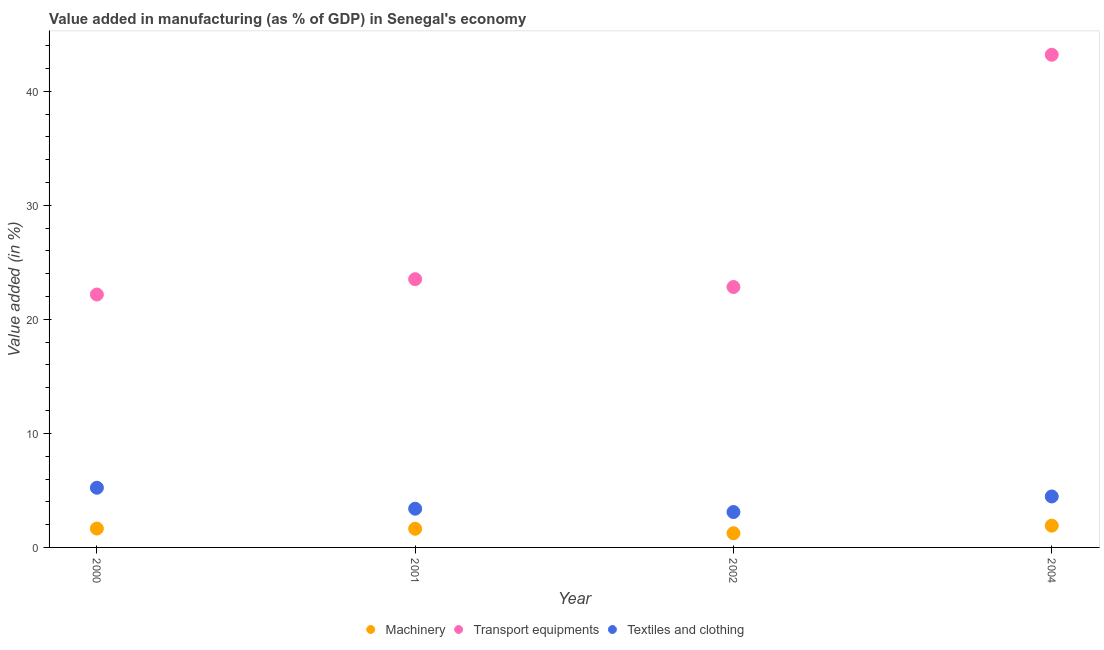What is the value added in manufacturing transport equipments in 2000?
Your response must be concise. 22.18. Across all years, what is the maximum value added in manufacturing textile and clothing?
Your answer should be very brief. 5.23. Across all years, what is the minimum value added in manufacturing transport equipments?
Give a very brief answer. 22.18. What is the total value added in manufacturing machinery in the graph?
Offer a terse response. 6.45. What is the difference between the value added in manufacturing transport equipments in 2001 and that in 2004?
Keep it short and to the point. -19.68. What is the difference between the value added in manufacturing machinery in 2002 and the value added in manufacturing transport equipments in 2004?
Provide a short and direct response. -41.96. What is the average value added in manufacturing transport equipments per year?
Offer a very short reply. 27.93. In the year 2002, what is the difference between the value added in manufacturing machinery and value added in manufacturing textile and clothing?
Ensure brevity in your answer.  -1.86. What is the ratio of the value added in manufacturing machinery in 2001 to that in 2002?
Keep it short and to the point. 1.31. Is the value added in manufacturing transport equipments in 2000 less than that in 2001?
Your response must be concise. Yes. What is the difference between the highest and the second highest value added in manufacturing textile and clothing?
Ensure brevity in your answer.  0.76. What is the difference between the highest and the lowest value added in manufacturing textile and clothing?
Offer a terse response. 2.13. Is the sum of the value added in manufacturing machinery in 2000 and 2002 greater than the maximum value added in manufacturing transport equipments across all years?
Keep it short and to the point. No. Is the value added in manufacturing transport equipments strictly greater than the value added in manufacturing machinery over the years?
Your answer should be very brief. Yes. How many dotlines are there?
Your answer should be compact. 3. What is the difference between two consecutive major ticks on the Y-axis?
Offer a very short reply. 10. Are the values on the major ticks of Y-axis written in scientific E-notation?
Keep it short and to the point. No. Does the graph contain any zero values?
Your answer should be compact. No. Does the graph contain grids?
Your answer should be compact. No. How many legend labels are there?
Offer a terse response. 3. What is the title of the graph?
Offer a terse response. Value added in manufacturing (as % of GDP) in Senegal's economy. Does "Transport" appear as one of the legend labels in the graph?
Your response must be concise. No. What is the label or title of the X-axis?
Ensure brevity in your answer.  Year. What is the label or title of the Y-axis?
Offer a terse response. Value added (in %). What is the Value added (in %) of Machinery in 2000?
Give a very brief answer. 1.66. What is the Value added (in %) in Transport equipments in 2000?
Ensure brevity in your answer.  22.18. What is the Value added (in %) in Textiles and clothing in 2000?
Ensure brevity in your answer.  5.23. What is the Value added (in %) in Machinery in 2001?
Ensure brevity in your answer.  1.64. What is the Value added (in %) of Transport equipments in 2001?
Ensure brevity in your answer.  23.52. What is the Value added (in %) of Textiles and clothing in 2001?
Your response must be concise. 3.39. What is the Value added (in %) in Machinery in 2002?
Your answer should be very brief. 1.25. What is the Value added (in %) in Transport equipments in 2002?
Ensure brevity in your answer.  22.84. What is the Value added (in %) of Textiles and clothing in 2002?
Your answer should be very brief. 3.1. What is the Value added (in %) of Machinery in 2004?
Provide a short and direct response. 1.91. What is the Value added (in %) in Transport equipments in 2004?
Offer a very short reply. 43.2. What is the Value added (in %) in Textiles and clothing in 2004?
Ensure brevity in your answer.  4.47. Across all years, what is the maximum Value added (in %) in Machinery?
Keep it short and to the point. 1.91. Across all years, what is the maximum Value added (in %) in Transport equipments?
Provide a succinct answer. 43.2. Across all years, what is the maximum Value added (in %) of Textiles and clothing?
Give a very brief answer. 5.23. Across all years, what is the minimum Value added (in %) in Machinery?
Offer a terse response. 1.25. Across all years, what is the minimum Value added (in %) of Transport equipments?
Make the answer very short. 22.18. Across all years, what is the minimum Value added (in %) in Textiles and clothing?
Keep it short and to the point. 3.1. What is the total Value added (in %) in Machinery in the graph?
Offer a terse response. 6.45. What is the total Value added (in %) of Transport equipments in the graph?
Keep it short and to the point. 111.74. What is the total Value added (in %) of Textiles and clothing in the graph?
Keep it short and to the point. 16.2. What is the difference between the Value added (in %) in Machinery in 2000 and that in 2001?
Provide a succinct answer. 0.02. What is the difference between the Value added (in %) in Transport equipments in 2000 and that in 2001?
Offer a terse response. -1.34. What is the difference between the Value added (in %) in Textiles and clothing in 2000 and that in 2001?
Provide a succinct answer. 1.84. What is the difference between the Value added (in %) of Machinery in 2000 and that in 2002?
Give a very brief answer. 0.41. What is the difference between the Value added (in %) of Transport equipments in 2000 and that in 2002?
Provide a short and direct response. -0.66. What is the difference between the Value added (in %) in Textiles and clothing in 2000 and that in 2002?
Your answer should be very brief. 2.13. What is the difference between the Value added (in %) in Machinery in 2000 and that in 2004?
Ensure brevity in your answer.  -0.25. What is the difference between the Value added (in %) of Transport equipments in 2000 and that in 2004?
Provide a succinct answer. -21.02. What is the difference between the Value added (in %) in Textiles and clothing in 2000 and that in 2004?
Offer a very short reply. 0.76. What is the difference between the Value added (in %) in Machinery in 2001 and that in 2002?
Keep it short and to the point. 0.39. What is the difference between the Value added (in %) in Transport equipments in 2001 and that in 2002?
Offer a terse response. 0.69. What is the difference between the Value added (in %) in Textiles and clothing in 2001 and that in 2002?
Your answer should be very brief. 0.29. What is the difference between the Value added (in %) in Machinery in 2001 and that in 2004?
Ensure brevity in your answer.  -0.27. What is the difference between the Value added (in %) of Transport equipments in 2001 and that in 2004?
Keep it short and to the point. -19.68. What is the difference between the Value added (in %) in Textiles and clothing in 2001 and that in 2004?
Give a very brief answer. -1.08. What is the difference between the Value added (in %) of Machinery in 2002 and that in 2004?
Provide a succinct answer. -0.66. What is the difference between the Value added (in %) of Transport equipments in 2002 and that in 2004?
Make the answer very short. -20.36. What is the difference between the Value added (in %) of Textiles and clothing in 2002 and that in 2004?
Provide a short and direct response. -1.37. What is the difference between the Value added (in %) of Machinery in 2000 and the Value added (in %) of Transport equipments in 2001?
Provide a short and direct response. -21.87. What is the difference between the Value added (in %) in Machinery in 2000 and the Value added (in %) in Textiles and clothing in 2001?
Your answer should be very brief. -1.74. What is the difference between the Value added (in %) of Transport equipments in 2000 and the Value added (in %) of Textiles and clothing in 2001?
Keep it short and to the point. 18.78. What is the difference between the Value added (in %) in Machinery in 2000 and the Value added (in %) in Transport equipments in 2002?
Make the answer very short. -21.18. What is the difference between the Value added (in %) in Machinery in 2000 and the Value added (in %) in Textiles and clothing in 2002?
Offer a terse response. -1.45. What is the difference between the Value added (in %) in Transport equipments in 2000 and the Value added (in %) in Textiles and clothing in 2002?
Your response must be concise. 19.07. What is the difference between the Value added (in %) of Machinery in 2000 and the Value added (in %) of Transport equipments in 2004?
Provide a succinct answer. -41.55. What is the difference between the Value added (in %) of Machinery in 2000 and the Value added (in %) of Textiles and clothing in 2004?
Make the answer very short. -2.81. What is the difference between the Value added (in %) of Transport equipments in 2000 and the Value added (in %) of Textiles and clothing in 2004?
Ensure brevity in your answer.  17.71. What is the difference between the Value added (in %) of Machinery in 2001 and the Value added (in %) of Transport equipments in 2002?
Your response must be concise. -21.2. What is the difference between the Value added (in %) in Machinery in 2001 and the Value added (in %) in Textiles and clothing in 2002?
Provide a short and direct response. -1.47. What is the difference between the Value added (in %) of Transport equipments in 2001 and the Value added (in %) of Textiles and clothing in 2002?
Provide a succinct answer. 20.42. What is the difference between the Value added (in %) of Machinery in 2001 and the Value added (in %) of Transport equipments in 2004?
Ensure brevity in your answer.  -41.56. What is the difference between the Value added (in %) in Machinery in 2001 and the Value added (in %) in Textiles and clothing in 2004?
Make the answer very short. -2.83. What is the difference between the Value added (in %) in Transport equipments in 2001 and the Value added (in %) in Textiles and clothing in 2004?
Provide a succinct answer. 19.05. What is the difference between the Value added (in %) in Machinery in 2002 and the Value added (in %) in Transport equipments in 2004?
Provide a succinct answer. -41.96. What is the difference between the Value added (in %) of Machinery in 2002 and the Value added (in %) of Textiles and clothing in 2004?
Make the answer very short. -3.22. What is the difference between the Value added (in %) in Transport equipments in 2002 and the Value added (in %) in Textiles and clothing in 2004?
Your answer should be compact. 18.37. What is the average Value added (in %) of Machinery per year?
Ensure brevity in your answer.  1.61. What is the average Value added (in %) of Transport equipments per year?
Provide a short and direct response. 27.93. What is the average Value added (in %) in Textiles and clothing per year?
Your answer should be compact. 4.05. In the year 2000, what is the difference between the Value added (in %) in Machinery and Value added (in %) in Transport equipments?
Offer a very short reply. -20.52. In the year 2000, what is the difference between the Value added (in %) of Machinery and Value added (in %) of Textiles and clothing?
Provide a succinct answer. -3.58. In the year 2000, what is the difference between the Value added (in %) in Transport equipments and Value added (in %) in Textiles and clothing?
Your answer should be compact. 16.94. In the year 2001, what is the difference between the Value added (in %) in Machinery and Value added (in %) in Transport equipments?
Ensure brevity in your answer.  -21.89. In the year 2001, what is the difference between the Value added (in %) of Machinery and Value added (in %) of Textiles and clothing?
Your answer should be compact. -1.76. In the year 2001, what is the difference between the Value added (in %) of Transport equipments and Value added (in %) of Textiles and clothing?
Keep it short and to the point. 20.13. In the year 2002, what is the difference between the Value added (in %) in Machinery and Value added (in %) in Transport equipments?
Provide a succinct answer. -21.59. In the year 2002, what is the difference between the Value added (in %) in Machinery and Value added (in %) in Textiles and clothing?
Provide a succinct answer. -1.86. In the year 2002, what is the difference between the Value added (in %) in Transport equipments and Value added (in %) in Textiles and clothing?
Make the answer very short. 19.73. In the year 2004, what is the difference between the Value added (in %) in Machinery and Value added (in %) in Transport equipments?
Provide a short and direct response. -41.29. In the year 2004, what is the difference between the Value added (in %) in Machinery and Value added (in %) in Textiles and clothing?
Keep it short and to the point. -2.56. In the year 2004, what is the difference between the Value added (in %) of Transport equipments and Value added (in %) of Textiles and clothing?
Make the answer very short. 38.73. What is the ratio of the Value added (in %) in Machinery in 2000 to that in 2001?
Give a very brief answer. 1.01. What is the ratio of the Value added (in %) in Transport equipments in 2000 to that in 2001?
Give a very brief answer. 0.94. What is the ratio of the Value added (in %) of Textiles and clothing in 2000 to that in 2001?
Give a very brief answer. 1.54. What is the ratio of the Value added (in %) in Machinery in 2000 to that in 2002?
Your answer should be very brief. 1.33. What is the ratio of the Value added (in %) in Transport equipments in 2000 to that in 2002?
Your answer should be compact. 0.97. What is the ratio of the Value added (in %) of Textiles and clothing in 2000 to that in 2002?
Provide a succinct answer. 1.69. What is the ratio of the Value added (in %) of Machinery in 2000 to that in 2004?
Provide a succinct answer. 0.87. What is the ratio of the Value added (in %) in Transport equipments in 2000 to that in 2004?
Your answer should be compact. 0.51. What is the ratio of the Value added (in %) of Textiles and clothing in 2000 to that in 2004?
Offer a very short reply. 1.17. What is the ratio of the Value added (in %) in Machinery in 2001 to that in 2002?
Provide a succinct answer. 1.31. What is the ratio of the Value added (in %) of Textiles and clothing in 2001 to that in 2002?
Provide a succinct answer. 1.09. What is the ratio of the Value added (in %) of Machinery in 2001 to that in 2004?
Give a very brief answer. 0.86. What is the ratio of the Value added (in %) in Transport equipments in 2001 to that in 2004?
Provide a short and direct response. 0.54. What is the ratio of the Value added (in %) in Textiles and clothing in 2001 to that in 2004?
Give a very brief answer. 0.76. What is the ratio of the Value added (in %) of Machinery in 2002 to that in 2004?
Offer a very short reply. 0.65. What is the ratio of the Value added (in %) of Transport equipments in 2002 to that in 2004?
Keep it short and to the point. 0.53. What is the ratio of the Value added (in %) in Textiles and clothing in 2002 to that in 2004?
Offer a very short reply. 0.69. What is the difference between the highest and the second highest Value added (in %) of Machinery?
Offer a terse response. 0.25. What is the difference between the highest and the second highest Value added (in %) in Transport equipments?
Your answer should be compact. 19.68. What is the difference between the highest and the second highest Value added (in %) in Textiles and clothing?
Ensure brevity in your answer.  0.76. What is the difference between the highest and the lowest Value added (in %) of Machinery?
Your answer should be compact. 0.66. What is the difference between the highest and the lowest Value added (in %) in Transport equipments?
Offer a terse response. 21.02. What is the difference between the highest and the lowest Value added (in %) in Textiles and clothing?
Make the answer very short. 2.13. 